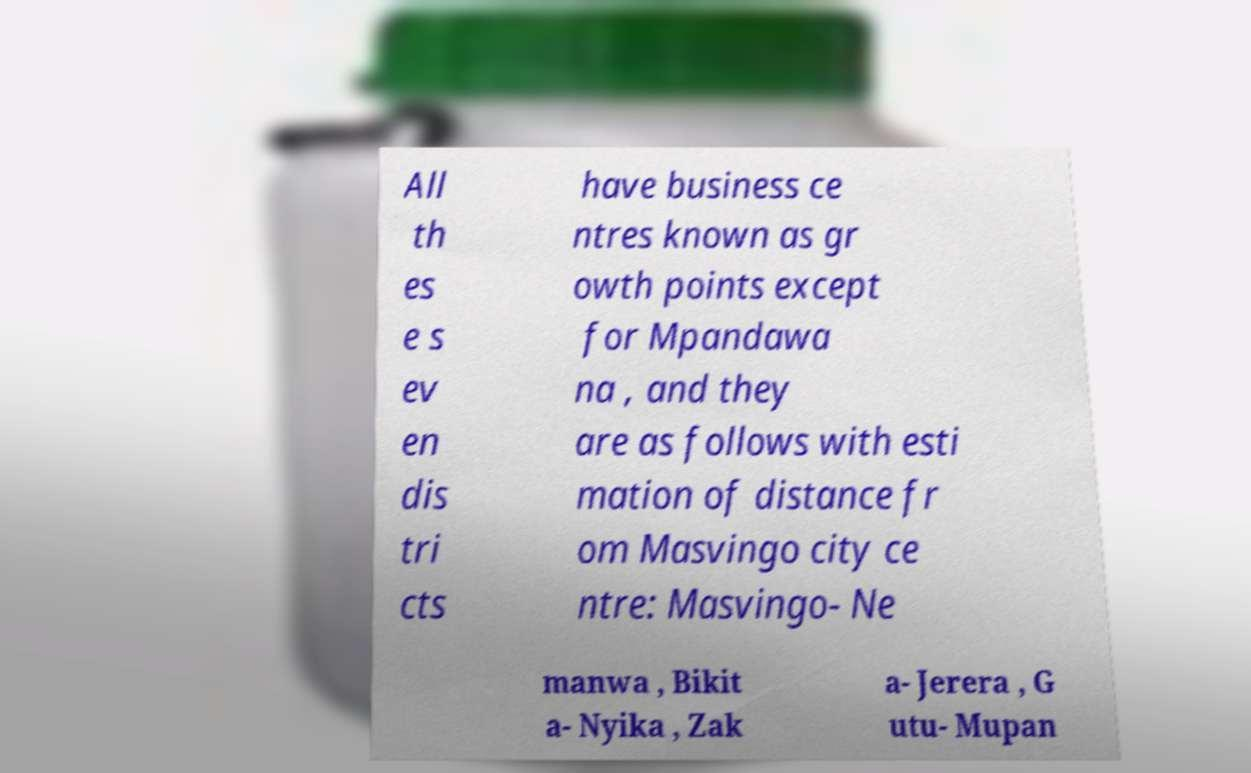I need the written content from this picture converted into text. Can you do that? All th es e s ev en dis tri cts have business ce ntres known as gr owth points except for Mpandawa na , and they are as follows with esti mation of distance fr om Masvingo city ce ntre: Masvingo- Ne manwa , Bikit a- Nyika , Zak a- Jerera , G utu- Mupan 